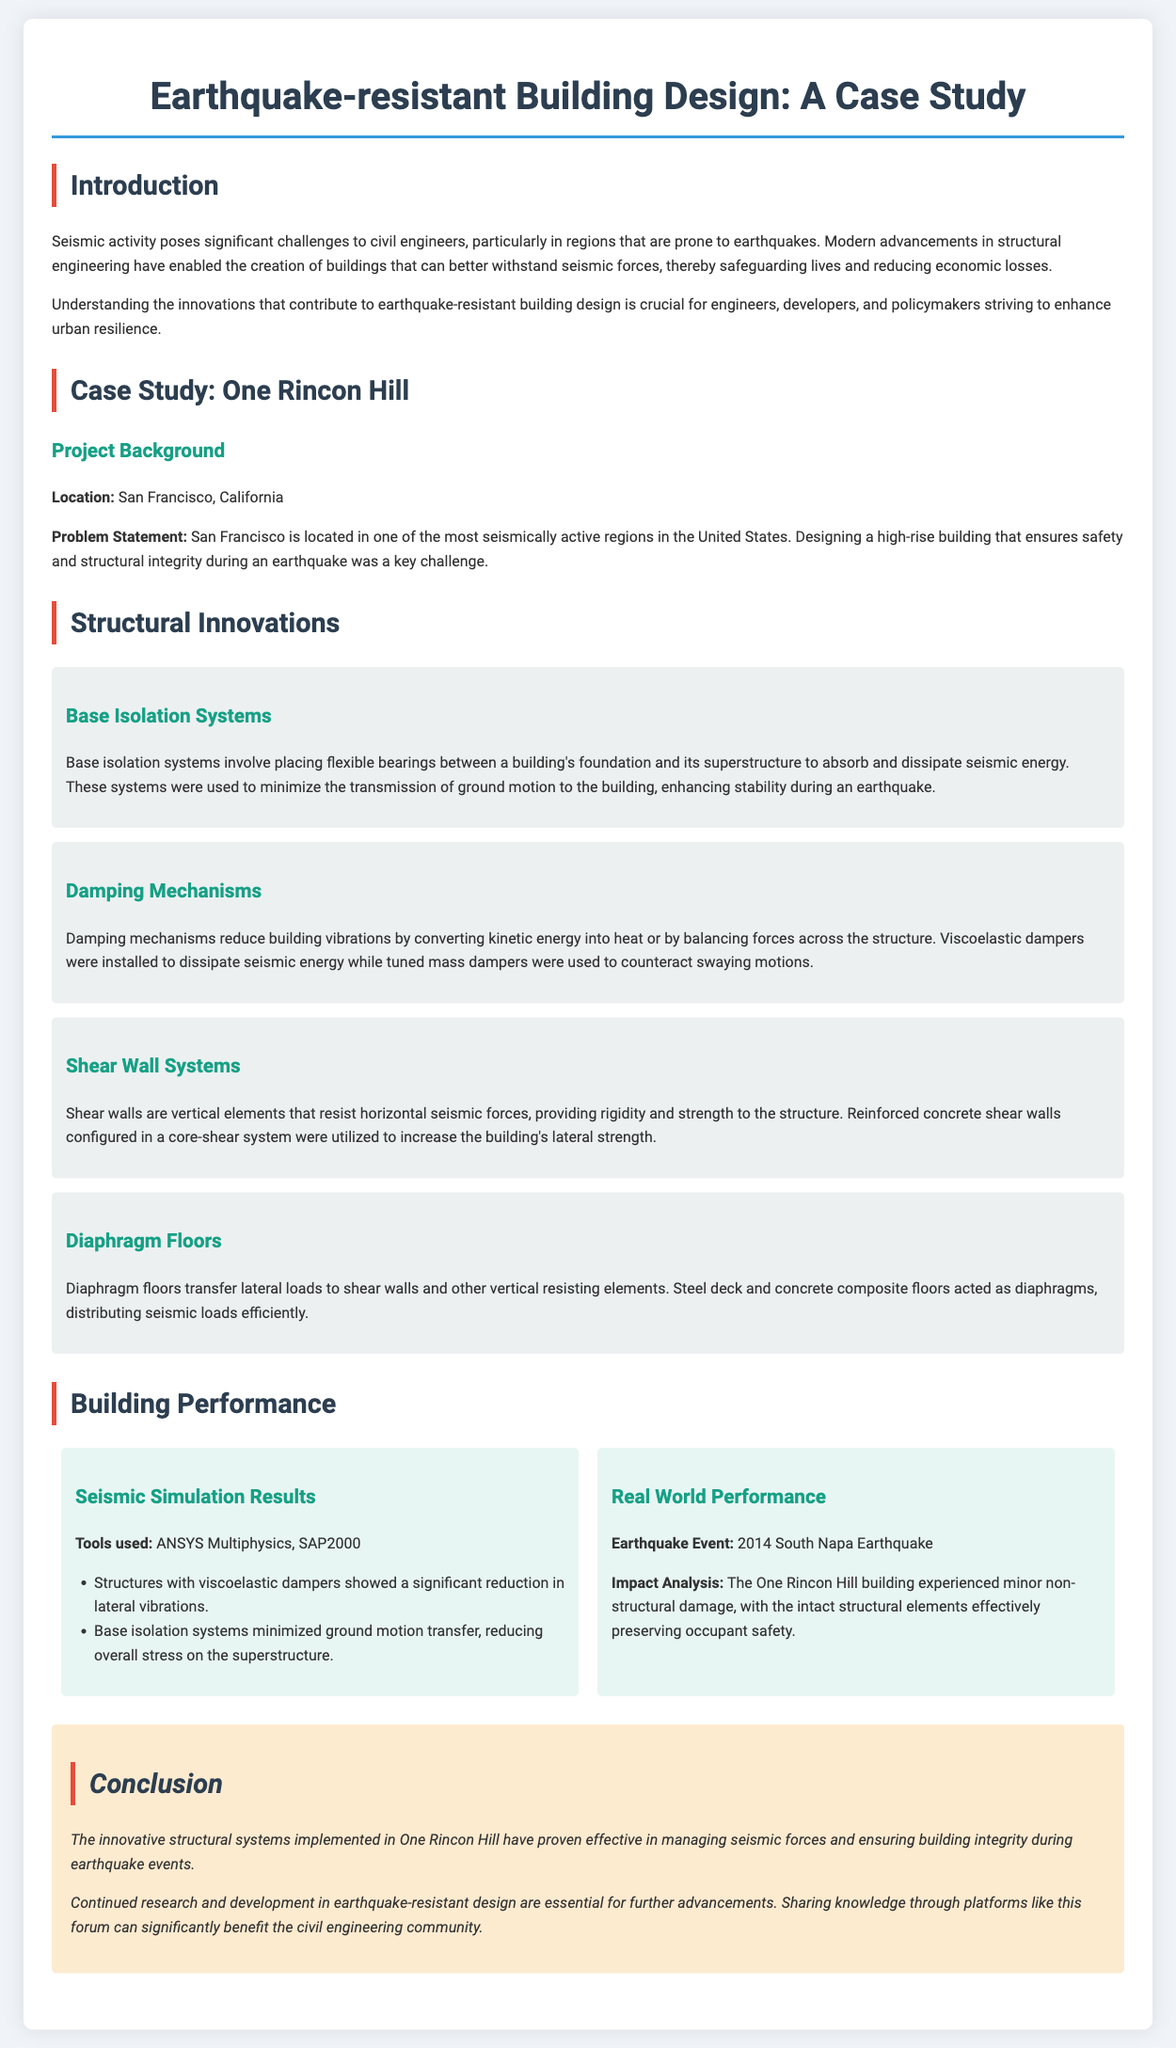What is the location of the case study? The case study focuses on a building located in San Francisco, California.
Answer: San Francisco, California What are the tools used for seismic simulation? The document lists ANSYS Multiphysics and SAP2000 as the tools used for seismic simulation.
Answer: ANSYS Multiphysics, SAP2000 What date did the South Napa Earthquake occur? The earthquake event mentioned in the document is dated in 2014.
Answer: 2014 What structural innovation involves placing flexible bearings? The document describes base isolation systems as innovations that involve placing flexible bearings.
Answer: Base Isolation Systems What was the impact on One Rincon Hill during the South Napa Earthquake? According to the document, the building experienced minor non-structural damage during the earthquake.
Answer: Minor non-structural damage Which innovation helps in reducing building vibrations? The document mentions damping mechanisms as innovations that reduce building vibrations.
Answer: Damping Mechanisms What is the primary focus of the document? The primary focus of the document is on earthquake-resistant building design.
Answer: Earthquake-resistant Building Design What type of walls are utilized for lateral strength? The document states that reinforced concrete shear walls are used to increase lateral strength.
Answer: Shear Walls What is the conclusion regarding One Rincon Hill's structural systems? The document concludes that the innovative structural systems have proven effective during earthquakes.
Answer: Proven effective during earthquakes 